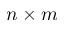Convert formula to latex. <formula><loc_0><loc_0><loc_500><loc_500>n \times m</formula> 